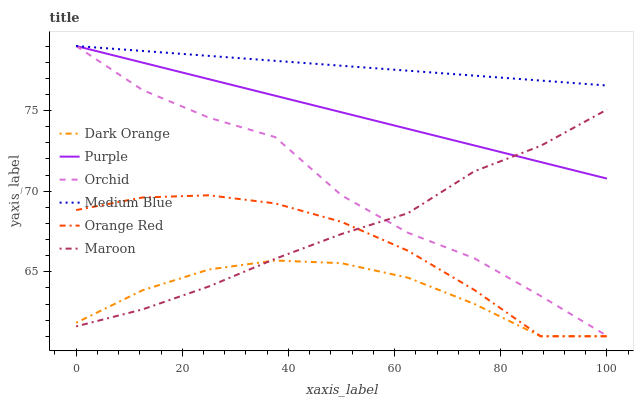Does Dark Orange have the minimum area under the curve?
Answer yes or no. Yes. Does Medium Blue have the maximum area under the curve?
Answer yes or no. Yes. Does Purple have the minimum area under the curve?
Answer yes or no. No. Does Purple have the maximum area under the curve?
Answer yes or no. No. Is Purple the smoothest?
Answer yes or no. Yes. Is Orchid the roughest?
Answer yes or no. Yes. Is Maroon the smoothest?
Answer yes or no. No. Is Maroon the roughest?
Answer yes or no. No. Does Dark Orange have the lowest value?
Answer yes or no. Yes. Does Purple have the lowest value?
Answer yes or no. No. Does Orchid have the highest value?
Answer yes or no. Yes. Does Maroon have the highest value?
Answer yes or no. No. Is Orange Red less than Medium Blue?
Answer yes or no. Yes. Is Purple greater than Orange Red?
Answer yes or no. Yes. Does Maroon intersect Orchid?
Answer yes or no. Yes. Is Maroon less than Orchid?
Answer yes or no. No. Is Maroon greater than Orchid?
Answer yes or no. No. Does Orange Red intersect Medium Blue?
Answer yes or no. No. 